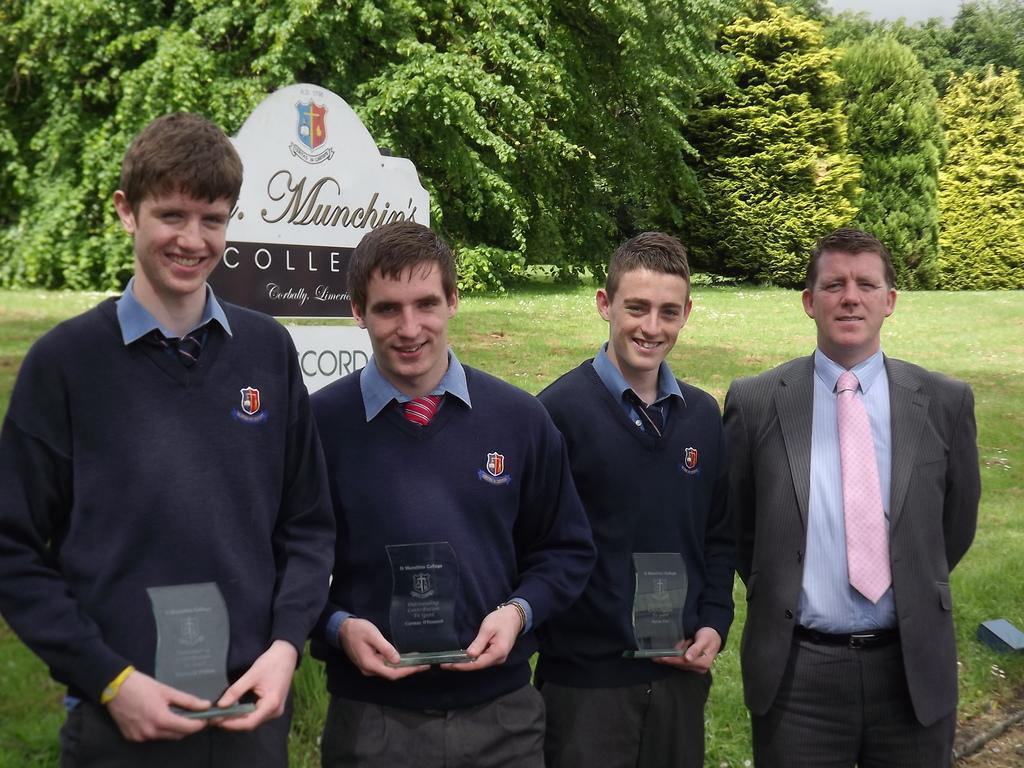Can you describe this image briefly? In the picture we can see four men, one man wearing suit and the other three wearing similar color dress holding some awards in their hands, in the background of the picture there is board, there are some trees, clear sky. 